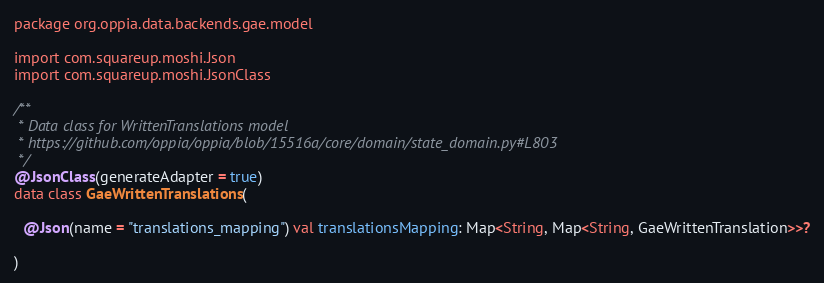Convert code to text. <code><loc_0><loc_0><loc_500><loc_500><_Kotlin_>package org.oppia.data.backends.gae.model

import com.squareup.moshi.Json
import com.squareup.moshi.JsonClass

/**
 * Data class for WrittenTranslations model
 * https://github.com/oppia/oppia/blob/15516a/core/domain/state_domain.py#L803
 */
@JsonClass(generateAdapter = true)
data class GaeWrittenTranslations(

  @Json(name = "translations_mapping") val translationsMapping: Map<String, Map<String, GaeWrittenTranslation>>?

)
</code> 